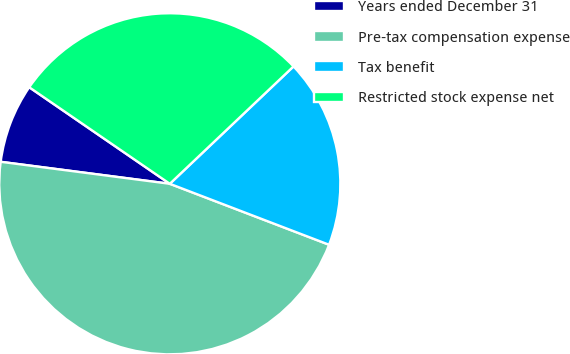Convert chart to OTSL. <chart><loc_0><loc_0><loc_500><loc_500><pie_chart><fcel>Years ended December 31<fcel>Pre-tax compensation expense<fcel>Tax benefit<fcel>Restricted stock expense net<nl><fcel>7.52%<fcel>46.24%<fcel>17.9%<fcel>28.34%<nl></chart> 